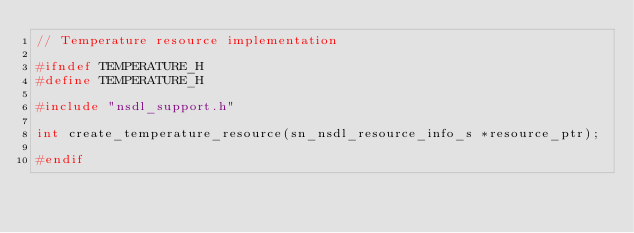<code> <loc_0><loc_0><loc_500><loc_500><_C_>// Temperature resource implementation

#ifndef TEMPERATURE_H
#define TEMPERATURE_H

#include "nsdl_support.h"

int create_temperature_resource(sn_nsdl_resource_info_s *resource_ptr);

#endif
</code> 